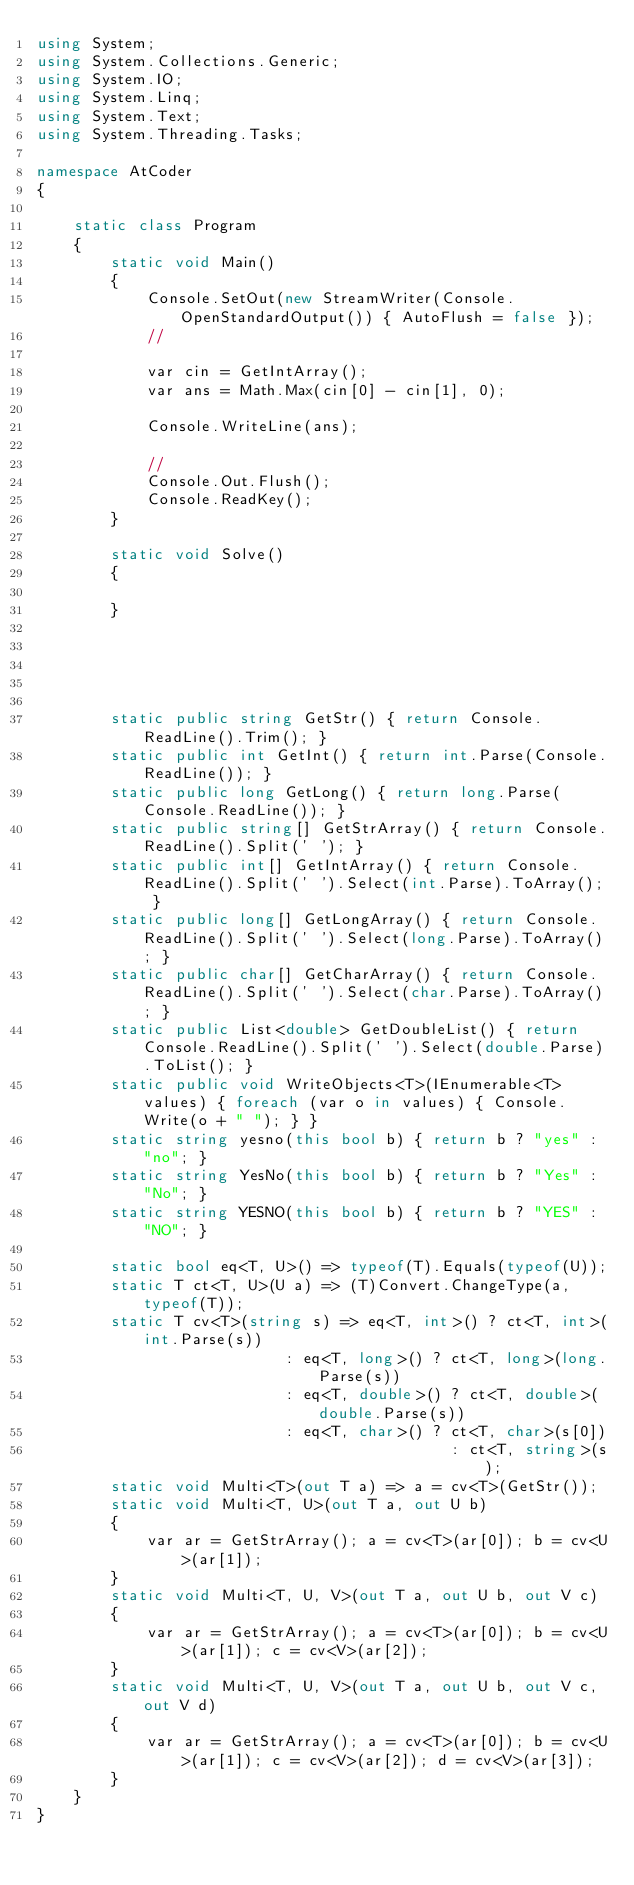<code> <loc_0><loc_0><loc_500><loc_500><_C#_>using System;
using System.Collections.Generic;
using System.IO;
using System.Linq;
using System.Text;
using System.Threading.Tasks;

namespace AtCoder
{

    static class Program
    {
        static void Main()
        {
            Console.SetOut(new StreamWriter(Console.OpenStandardOutput()) { AutoFlush = false });
            //

            var cin = GetIntArray();
            var ans = Math.Max(cin[0] - cin[1], 0);

            Console.WriteLine(ans);

            //
            Console.Out.Flush();
            Console.ReadKey();
        }

        static void Solve()
        {

        }





        static public string GetStr() { return Console.ReadLine().Trim(); }
        static public int GetInt() { return int.Parse(Console.ReadLine()); }
        static public long GetLong() { return long.Parse(Console.ReadLine()); }
        static public string[] GetStrArray() { return Console.ReadLine().Split(' '); }
        static public int[] GetIntArray() { return Console.ReadLine().Split(' ').Select(int.Parse).ToArray(); }
        static public long[] GetLongArray() { return Console.ReadLine().Split(' ').Select(long.Parse).ToArray(); }
        static public char[] GetCharArray() { return Console.ReadLine().Split(' ').Select(char.Parse).ToArray(); }
        static public List<double> GetDoubleList() { return Console.ReadLine().Split(' ').Select(double.Parse).ToList(); }
        static public void WriteObjects<T>(IEnumerable<T> values) { foreach (var o in values) { Console.Write(o + " "); } }
        static string yesno(this bool b) { return b ? "yes" : "no"; }
        static string YesNo(this bool b) { return b ? "Yes" : "No"; }
        static string YESNO(this bool b) { return b ? "YES" : "NO"; }

        static bool eq<T, U>() => typeof(T).Equals(typeof(U));
        static T ct<T, U>(U a) => (T)Convert.ChangeType(a, typeof(T));
        static T cv<T>(string s) => eq<T, int>() ? ct<T, int>(int.Parse(s))
                           : eq<T, long>() ? ct<T, long>(long.Parse(s))
                           : eq<T, double>() ? ct<T, double>(double.Parse(s))
                           : eq<T, char>() ? ct<T, char>(s[0])
                                             : ct<T, string>(s);
        static void Multi<T>(out T a) => a = cv<T>(GetStr());
        static void Multi<T, U>(out T a, out U b)
        {
            var ar = GetStrArray(); a = cv<T>(ar[0]); b = cv<U>(ar[1]);
        }
        static void Multi<T, U, V>(out T a, out U b, out V c)
        {
            var ar = GetStrArray(); a = cv<T>(ar[0]); b = cv<U>(ar[1]); c = cv<V>(ar[2]);
        }
        static void Multi<T, U, V>(out T a, out U b, out V c, out V d)
        {
            var ar = GetStrArray(); a = cv<T>(ar[0]); b = cv<U>(ar[1]); c = cv<V>(ar[2]); d = cv<V>(ar[3]);
        }
    }
}</code> 